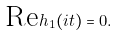Convert formula to latex. <formula><loc_0><loc_0><loc_500><loc_500>\text {Re} h _ { 1 } ( i t ) = 0 .</formula> 